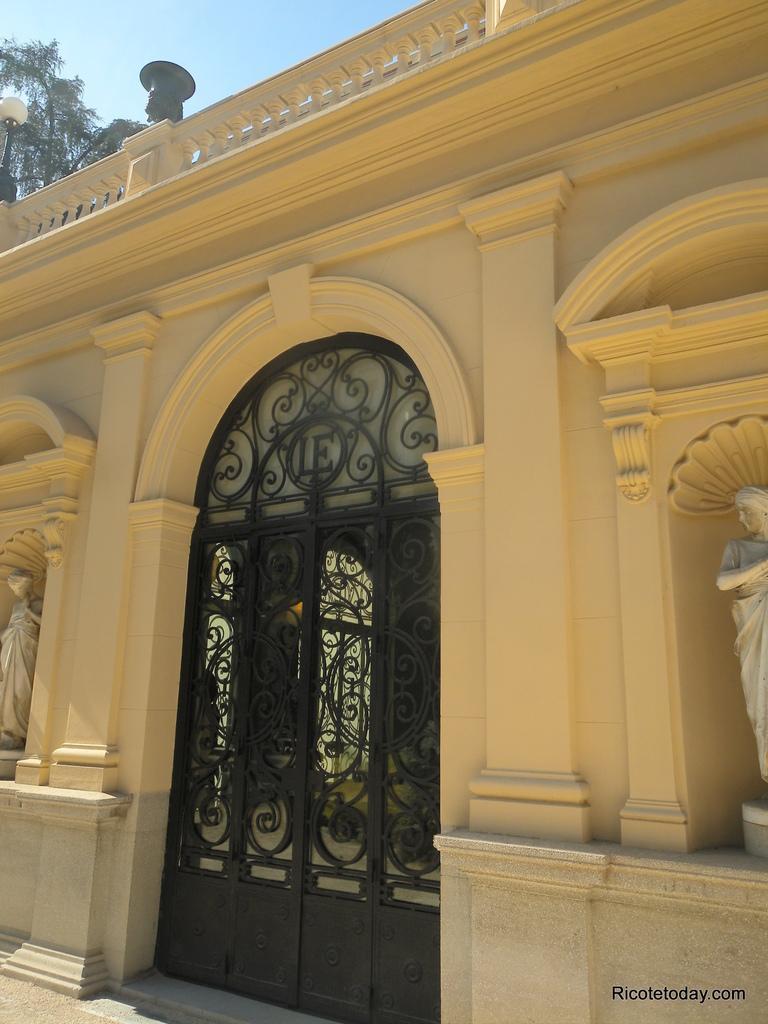Can you describe this image briefly? In this image, we can see a grill doors, wall, sculptures, tree, railings, pillar, pole with light. At the bottom, there is a walkway. Top of the image, there is a sky. Right side bottom of the image, we can see the watermark. 